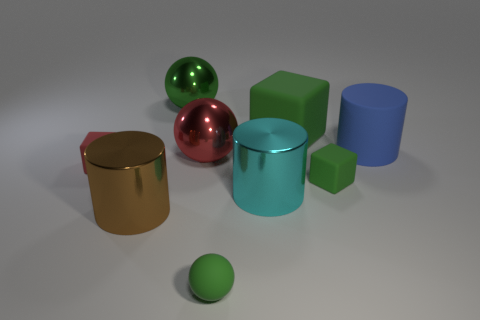There is a large sphere that is the same color as the big cube; what material is it?
Keep it short and to the point. Metal. What number of other objects are the same color as the big cube?
Offer a terse response. 3. What color is the large metallic cylinder left of the large green thing that is on the left side of the big green matte object?
Keep it short and to the point. Brown. Are there any balls that have the same color as the large block?
Provide a succinct answer. Yes. What number of metal objects are tiny green balls or big green cubes?
Make the answer very short. 0. Is there another red cube that has the same material as the big cube?
Provide a succinct answer. Yes. How many green matte objects are behind the blue matte thing and in front of the rubber cylinder?
Ensure brevity in your answer.  0. Are there fewer large metallic cylinders that are behind the red rubber thing than red things that are to the right of the big cyan cylinder?
Give a very brief answer. No. Does the brown metallic thing have the same shape as the big blue thing?
Your answer should be very brief. Yes. What number of other things are the same size as the green metallic thing?
Offer a very short reply. 5. 